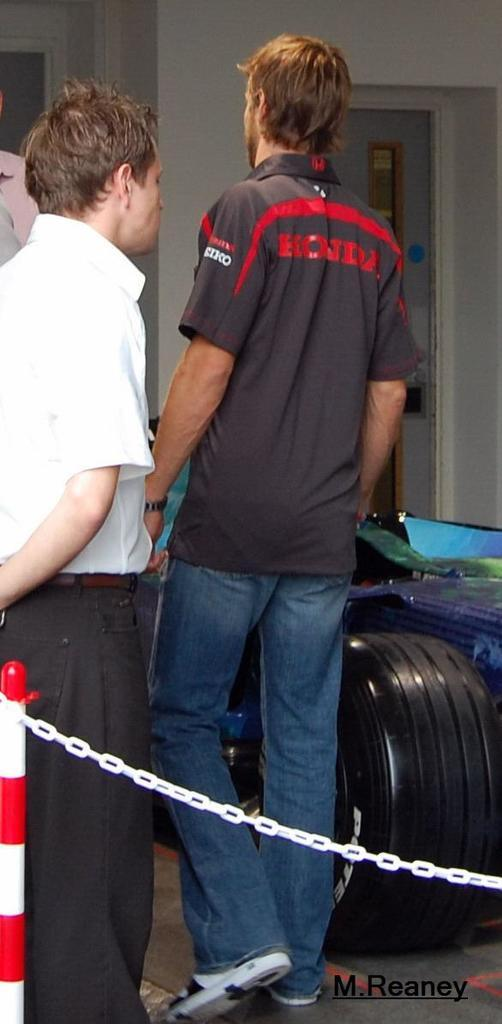How many people are in the image? There are two persons in the image. What are the actions of the two persons? One person is standing, and the other is walking. What object can be seen behind one of the persons? There is a tyre behind one of the persons. What can be seen in the background of the image? There is a wall in the background of the image. Reasoning: Let' Let's think step by step in order to produce the conversation. We start by identifying the number of people in the image, which is two. Then, we describe their actions, noting that one is standing and the other is walking. Next, we mention the object behind one of the persons, which is a tyre. Finally, we describe the background, which includes a wall. Absurd Question/Answer: What type of powder is being used by the person on the skate in the image? There is no person on a skate or any powder present in the image. 